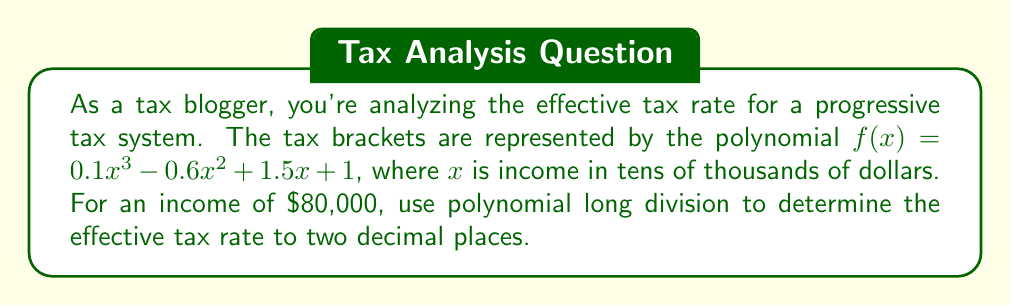Provide a solution to this math problem. To solve this problem, we need to perform the following steps:

1) First, we need to evaluate $f(8)$ since $80,000 corresponds to $x = 8$ in our polynomial.

   $f(8) = 0.1(8^3) - 0.6(8^2) + 1.5(8) + 1$
   $= 51.2 - 38.4 + 12 + 1$
   $= 25.8$

   This means the total tax on $80,000 is $25,800.

2) To find the effective tax rate, we need to divide the tax by the income:

   Effective Tax Rate = $\frac{25800}{80000} = 0.3225$

3) However, the question asks us to use polynomial long division. We can interpret this as dividing $f(x)$ by $x$:

   $$\frac{0.1x^3 - 0.6x^2 + 1.5x + 1}{x}$$

4) Performing the long division:

   $$
   \begin{array}{r}
   0.1x^2 - 0.6x + 1.5 + \frac{1}{x} \\
   x \enclose{longdiv}{0.1x^3 - 0.6x^2 + 1.5x + 1} \\
   \underline{0.1x^3 - 0.6x^2 + 1.5x} \\
   1
   \end{array}
   $$

5) The result of the division is $0.1x^2 - 0.6x + 1.5 + \frac{1}{x}$

6) This polynomial represents the effective tax rate as a function of income. To get the effective tax rate for $80,000, we evaluate this at $x = 8$:

   $0.1(8^2) - 0.6(8) + 1.5 + \frac{1}{8}$
   $= 6.4 - 4.8 + 1.5 + 0.125$
   $= 3.225$

7) This gives us 0.3225 or 32.25% when expressed as a percentage.
Answer: The effective tax rate for an income of $80,000 is 32.25%. 